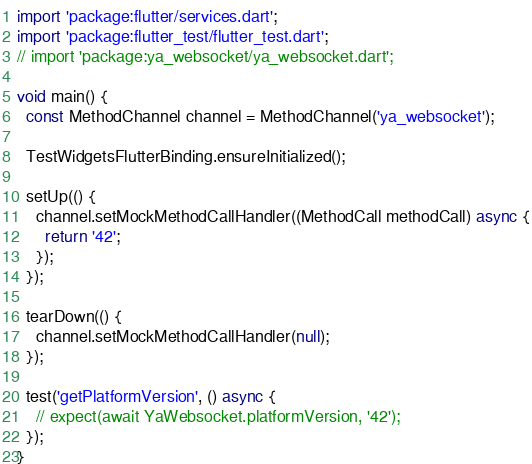<code> <loc_0><loc_0><loc_500><loc_500><_Dart_>import 'package:flutter/services.dart';
import 'package:flutter_test/flutter_test.dart';
// import 'package:ya_websocket/ya_websocket.dart';

void main() {
  const MethodChannel channel = MethodChannel('ya_websocket');

  TestWidgetsFlutterBinding.ensureInitialized();

  setUp(() {
    channel.setMockMethodCallHandler((MethodCall methodCall) async {
      return '42';
    });
  });

  tearDown(() {
    channel.setMockMethodCallHandler(null);
  });

  test('getPlatformVersion', () async {
    // expect(await YaWebsocket.platformVersion, '42');
  });
}
</code> 